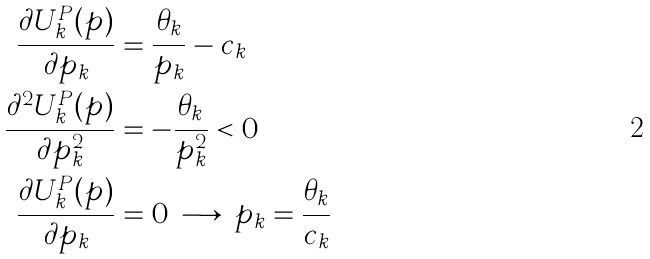<formula> <loc_0><loc_0><loc_500><loc_500>\frac { \partial U _ { k } ^ { P } ( p ) } { \partial p _ { k } } & = \frac { \theta _ { k } } { p _ { k } } - c _ { k } \\ \frac { \partial ^ { 2 } U _ { k } ^ { P } ( p ) } { \partial p _ { k } ^ { 2 } } & = - \frac { \theta _ { k } } { p _ { k } ^ { 2 } } < 0 \\ \frac { \partial U _ { k } ^ { P } ( p ) } { \partial p _ { k } } & = 0 \, \longrightarrow \, p _ { k } = \frac { \theta _ { k } } { c _ { k } }</formula> 